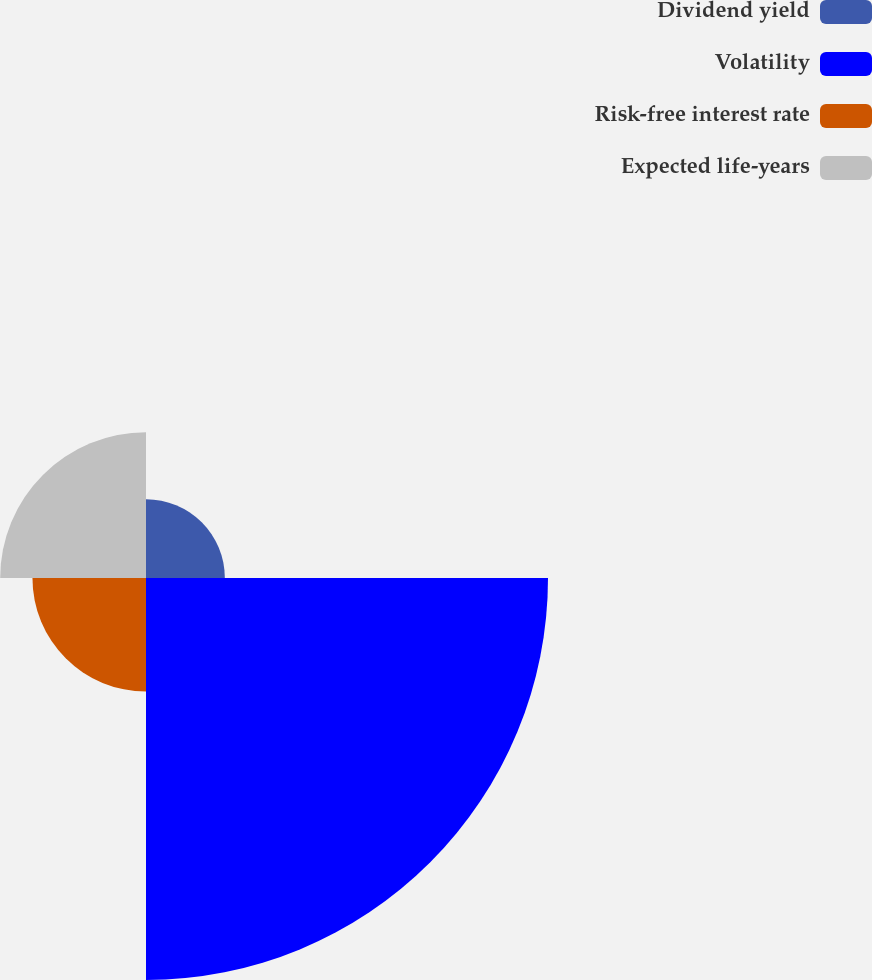Convert chart. <chart><loc_0><loc_0><loc_500><loc_500><pie_chart><fcel>Dividend yield<fcel>Volatility<fcel>Risk-free interest rate<fcel>Expected life-years<nl><fcel>10.65%<fcel>54.31%<fcel>15.34%<fcel>19.7%<nl></chart> 